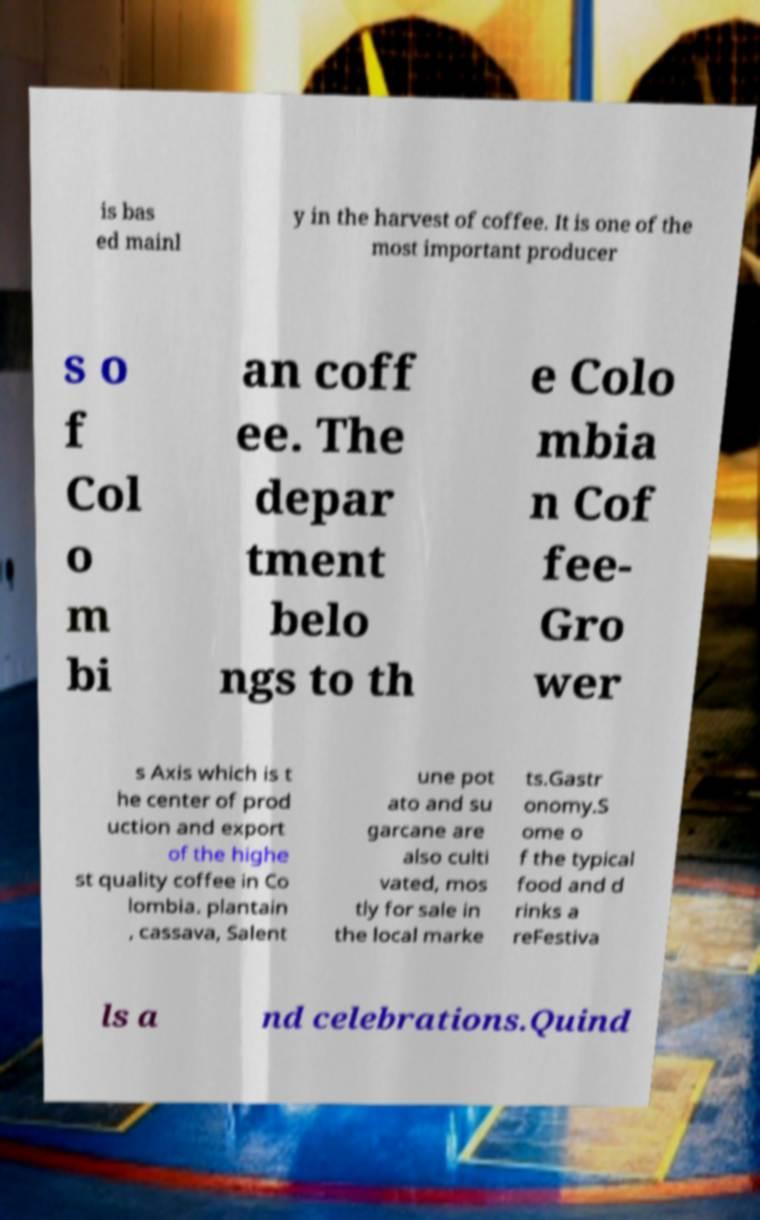For documentation purposes, I need the text within this image transcribed. Could you provide that? is bas ed mainl y in the harvest of coffee. It is one of the most important producer s o f Col o m bi an coff ee. The depar tment belo ngs to th e Colo mbia n Cof fee- Gro wer s Axis which is t he center of prod uction and export of the highe st quality coffee in Co lombia. plantain , cassava, Salent une pot ato and su garcane are also culti vated, mos tly for sale in the local marke ts.Gastr onomy.S ome o f the typical food and d rinks a reFestiva ls a nd celebrations.Quind 